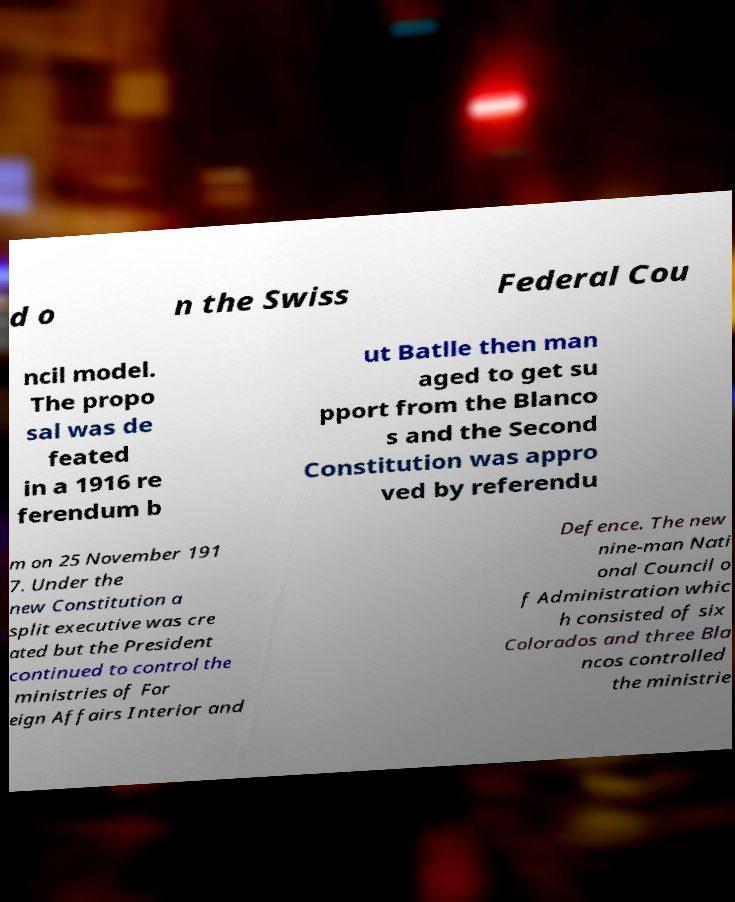Could you extract and type out the text from this image? d o n the Swiss Federal Cou ncil model. The propo sal was de feated in a 1916 re ferendum b ut Batlle then man aged to get su pport from the Blanco s and the Second Constitution was appro ved by referendu m on 25 November 191 7. Under the new Constitution a split executive was cre ated but the President continued to control the ministries of For eign Affairs Interior and Defence. The new nine-man Nati onal Council o f Administration whic h consisted of six Colorados and three Bla ncos controlled the ministrie 